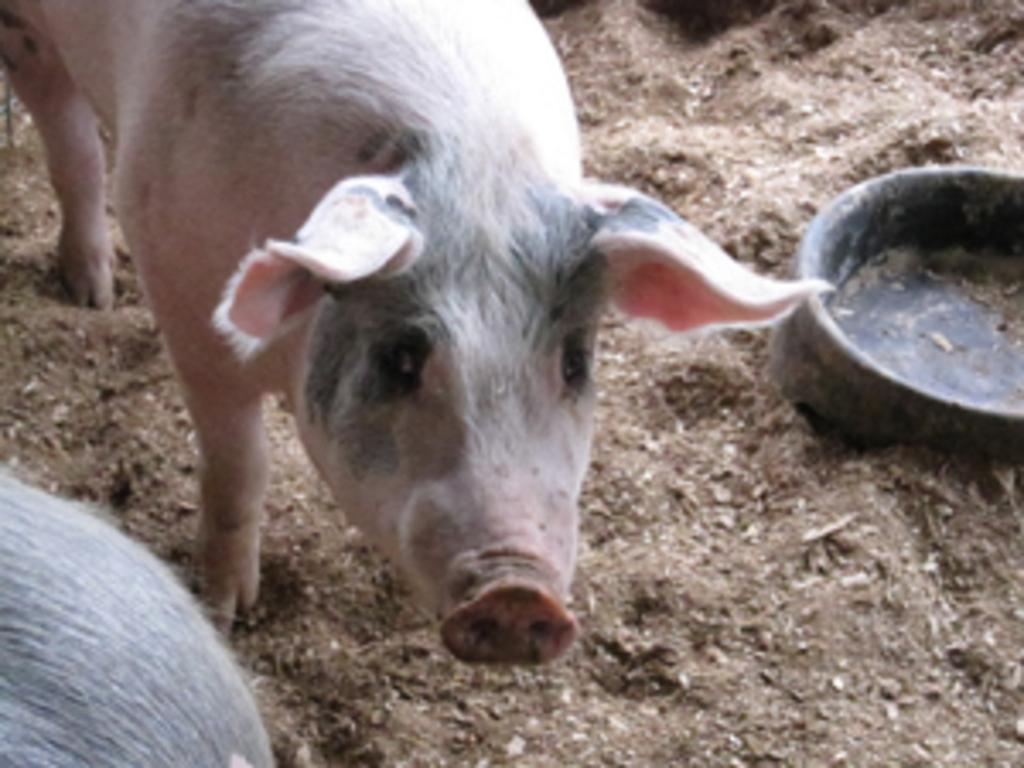What animal is present in the image? There is a pig in the image. Where is the pig located in the image? The pig is standing on a path in the image. What can be seen on the right side of the image? There is a bowl on the right side of the image. What type of chance game is being played in the image? There is no chance game present in the image; it features a pig standing on a path and a bowl on the right side. 